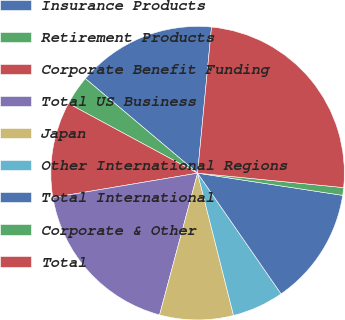Convert chart to OTSL. <chart><loc_0><loc_0><loc_500><loc_500><pie_chart><fcel>Insurance Products<fcel>Retirement Products<fcel>Corporate Benefit Funding<fcel>Total US Business<fcel>Japan<fcel>Other International Regions<fcel>Total International<fcel>Corporate & Other<fcel>Total<nl><fcel>15.37%<fcel>3.27%<fcel>10.53%<fcel>18.17%<fcel>8.11%<fcel>5.69%<fcel>12.95%<fcel>0.85%<fcel>25.05%<nl></chart> 